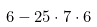<formula> <loc_0><loc_0><loc_500><loc_500>6 - 2 5 \cdot 7 \cdot 6</formula> 